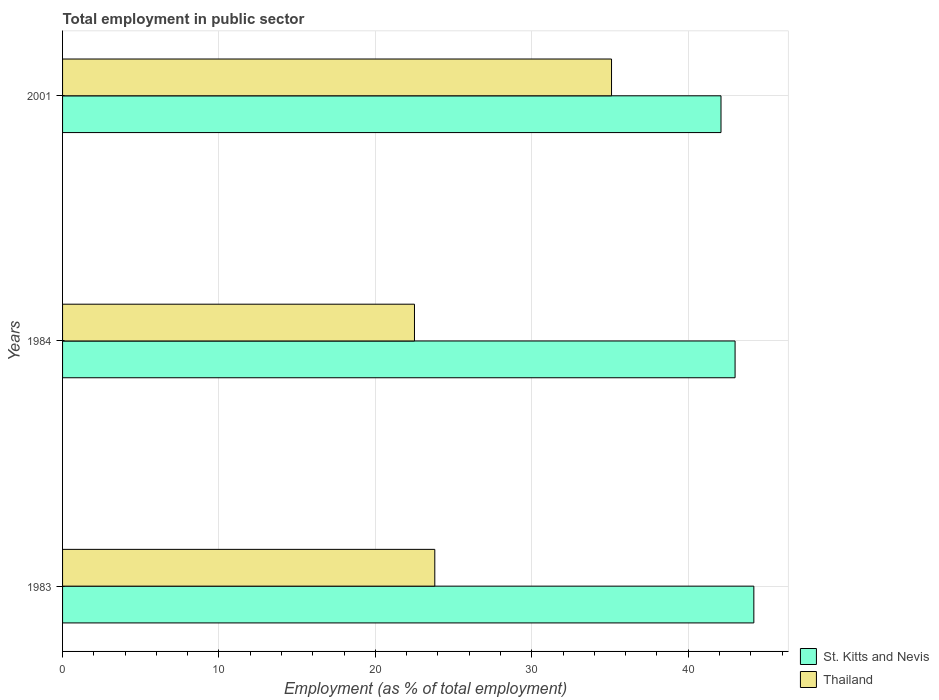How many different coloured bars are there?
Ensure brevity in your answer.  2. How many groups of bars are there?
Provide a short and direct response. 3. Are the number of bars per tick equal to the number of legend labels?
Your answer should be very brief. Yes. How many bars are there on the 2nd tick from the top?
Your answer should be very brief. 2. How many bars are there on the 3rd tick from the bottom?
Give a very brief answer. 2. Across all years, what is the maximum employment in public sector in St. Kitts and Nevis?
Give a very brief answer. 44.2. Across all years, what is the minimum employment in public sector in Thailand?
Provide a short and direct response. 22.5. In which year was the employment in public sector in St. Kitts and Nevis maximum?
Keep it short and to the point. 1983. What is the total employment in public sector in St. Kitts and Nevis in the graph?
Your answer should be very brief. 129.3. What is the difference between the employment in public sector in Thailand in 1983 and that in 2001?
Give a very brief answer. -11.3. What is the difference between the employment in public sector in St. Kitts and Nevis in 2001 and the employment in public sector in Thailand in 1984?
Provide a short and direct response. 19.6. What is the average employment in public sector in St. Kitts and Nevis per year?
Make the answer very short. 43.1. In the year 1983, what is the difference between the employment in public sector in Thailand and employment in public sector in St. Kitts and Nevis?
Provide a succinct answer. -20.4. In how many years, is the employment in public sector in St. Kitts and Nevis greater than 8 %?
Give a very brief answer. 3. What is the ratio of the employment in public sector in Thailand in 1984 to that in 2001?
Your answer should be compact. 0.64. Is the employment in public sector in Thailand in 1983 less than that in 1984?
Your answer should be compact. No. What is the difference between the highest and the second highest employment in public sector in St. Kitts and Nevis?
Offer a terse response. 1.2. What is the difference between the highest and the lowest employment in public sector in St. Kitts and Nevis?
Provide a short and direct response. 2.1. What does the 1st bar from the top in 2001 represents?
Provide a succinct answer. Thailand. What does the 1st bar from the bottom in 1984 represents?
Keep it short and to the point. St. Kitts and Nevis. How many bars are there?
Ensure brevity in your answer.  6. Are all the bars in the graph horizontal?
Keep it short and to the point. Yes. How many years are there in the graph?
Ensure brevity in your answer.  3. Does the graph contain grids?
Offer a terse response. Yes. How many legend labels are there?
Your answer should be compact. 2. What is the title of the graph?
Provide a short and direct response. Total employment in public sector. What is the label or title of the X-axis?
Make the answer very short. Employment (as % of total employment). What is the Employment (as % of total employment) in St. Kitts and Nevis in 1983?
Your answer should be compact. 44.2. What is the Employment (as % of total employment) in Thailand in 1983?
Offer a very short reply. 23.8. What is the Employment (as % of total employment) in Thailand in 1984?
Provide a succinct answer. 22.5. What is the Employment (as % of total employment) in St. Kitts and Nevis in 2001?
Your answer should be very brief. 42.1. What is the Employment (as % of total employment) of Thailand in 2001?
Provide a short and direct response. 35.1. Across all years, what is the maximum Employment (as % of total employment) of St. Kitts and Nevis?
Offer a very short reply. 44.2. Across all years, what is the maximum Employment (as % of total employment) in Thailand?
Your response must be concise. 35.1. Across all years, what is the minimum Employment (as % of total employment) in St. Kitts and Nevis?
Your response must be concise. 42.1. What is the total Employment (as % of total employment) of St. Kitts and Nevis in the graph?
Your answer should be very brief. 129.3. What is the total Employment (as % of total employment) in Thailand in the graph?
Make the answer very short. 81.4. What is the difference between the Employment (as % of total employment) in Thailand in 1983 and that in 1984?
Keep it short and to the point. 1.3. What is the difference between the Employment (as % of total employment) of St. Kitts and Nevis in 1983 and that in 2001?
Keep it short and to the point. 2.1. What is the difference between the Employment (as % of total employment) in Thailand in 1983 and that in 2001?
Make the answer very short. -11.3. What is the difference between the Employment (as % of total employment) in St. Kitts and Nevis in 1983 and the Employment (as % of total employment) in Thailand in 1984?
Provide a succinct answer. 21.7. What is the difference between the Employment (as % of total employment) in St. Kitts and Nevis in 1983 and the Employment (as % of total employment) in Thailand in 2001?
Your answer should be compact. 9.1. What is the difference between the Employment (as % of total employment) of St. Kitts and Nevis in 1984 and the Employment (as % of total employment) of Thailand in 2001?
Offer a very short reply. 7.9. What is the average Employment (as % of total employment) in St. Kitts and Nevis per year?
Your response must be concise. 43.1. What is the average Employment (as % of total employment) of Thailand per year?
Your answer should be very brief. 27.13. In the year 1983, what is the difference between the Employment (as % of total employment) of St. Kitts and Nevis and Employment (as % of total employment) of Thailand?
Keep it short and to the point. 20.4. In the year 1984, what is the difference between the Employment (as % of total employment) in St. Kitts and Nevis and Employment (as % of total employment) in Thailand?
Your answer should be compact. 20.5. What is the ratio of the Employment (as % of total employment) in St. Kitts and Nevis in 1983 to that in 1984?
Provide a succinct answer. 1.03. What is the ratio of the Employment (as % of total employment) in Thailand in 1983 to that in 1984?
Your response must be concise. 1.06. What is the ratio of the Employment (as % of total employment) in St. Kitts and Nevis in 1983 to that in 2001?
Keep it short and to the point. 1.05. What is the ratio of the Employment (as % of total employment) of Thailand in 1983 to that in 2001?
Offer a terse response. 0.68. What is the ratio of the Employment (as % of total employment) of St. Kitts and Nevis in 1984 to that in 2001?
Keep it short and to the point. 1.02. What is the ratio of the Employment (as % of total employment) of Thailand in 1984 to that in 2001?
Your answer should be compact. 0.64. What is the difference between the highest and the second highest Employment (as % of total employment) of Thailand?
Make the answer very short. 11.3. What is the difference between the highest and the lowest Employment (as % of total employment) of St. Kitts and Nevis?
Give a very brief answer. 2.1. What is the difference between the highest and the lowest Employment (as % of total employment) of Thailand?
Your response must be concise. 12.6. 